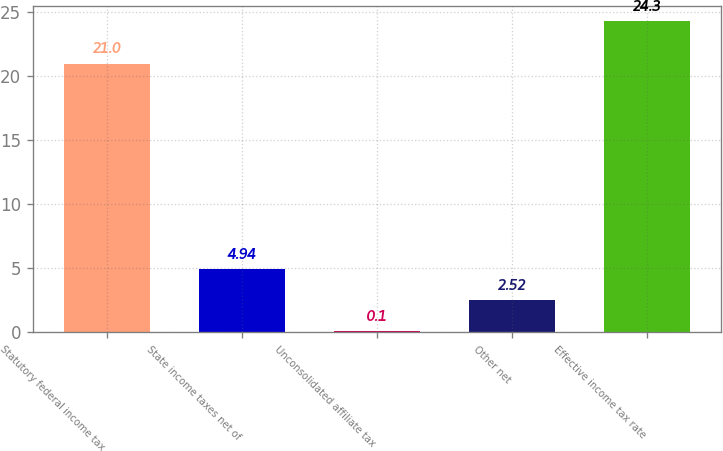Convert chart. <chart><loc_0><loc_0><loc_500><loc_500><bar_chart><fcel>Statutory federal income tax<fcel>State income taxes net of<fcel>Unconsolidated affiliate tax<fcel>Other net<fcel>Effective income tax rate<nl><fcel>21<fcel>4.94<fcel>0.1<fcel>2.52<fcel>24.3<nl></chart> 